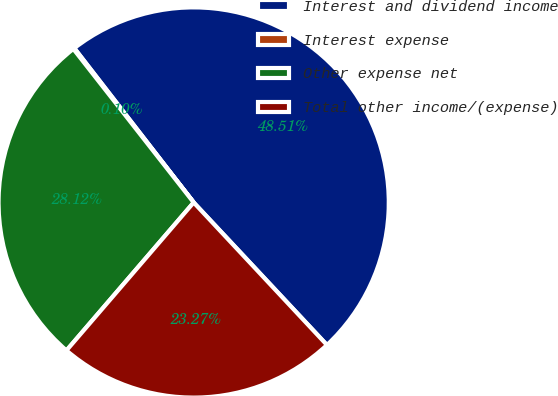<chart> <loc_0><loc_0><loc_500><loc_500><pie_chart><fcel>Interest and dividend income<fcel>Interest expense<fcel>Other expense net<fcel>Total other income/(expense)<nl><fcel>48.51%<fcel>0.1%<fcel>28.12%<fcel>23.27%<nl></chart> 